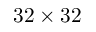<formula> <loc_0><loc_0><loc_500><loc_500>3 2 \times 3 2</formula> 